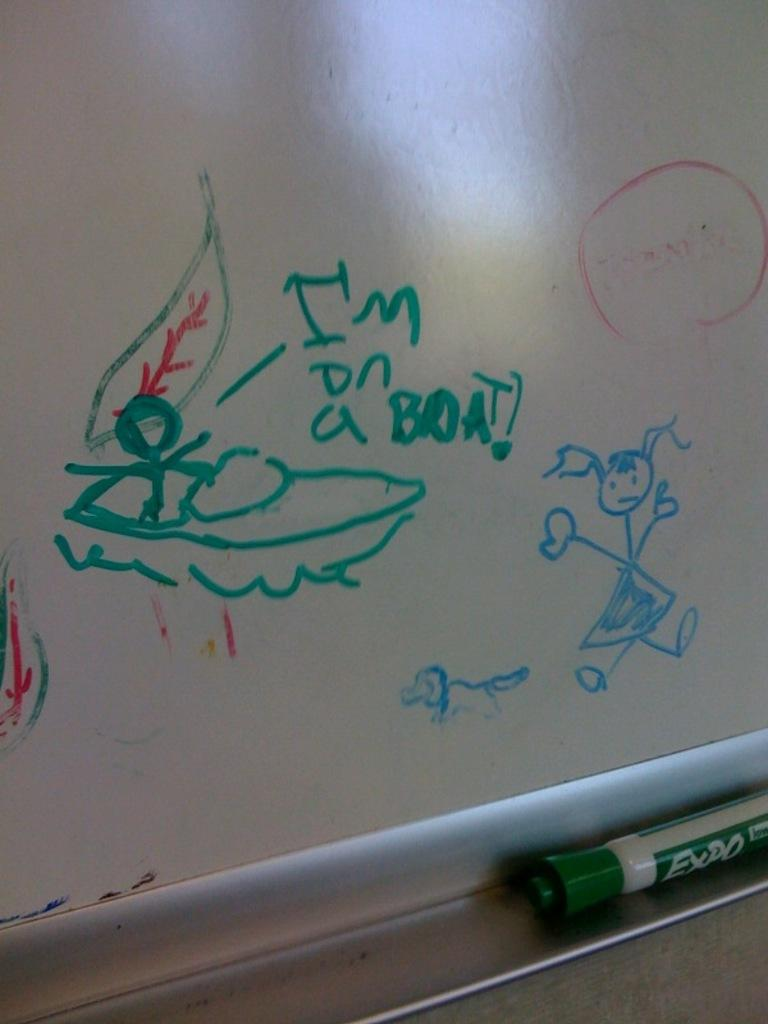Provide a one-sentence caption for the provided image. A white board has a picture of a boat and I'm on a boat in green. 